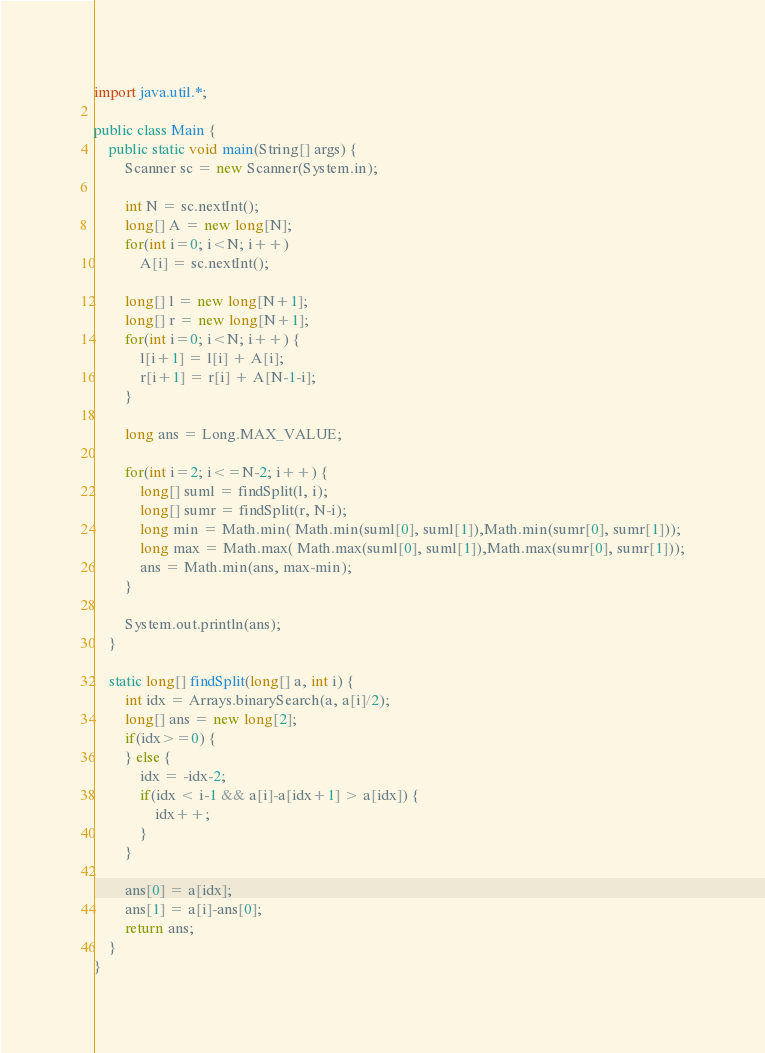<code> <loc_0><loc_0><loc_500><loc_500><_Java_>import java.util.*;

public class Main {
	public static void main(String[] args) {
		Scanner sc = new Scanner(System.in);
		
		int N = sc.nextInt();
		long[] A = new long[N];
		for(int i=0; i<N; i++)
			A[i] = sc.nextInt();
		
		long[] l = new long[N+1];
		long[] r = new long[N+1];
		for(int i=0; i<N; i++) {
			l[i+1] = l[i] + A[i];
			r[i+1] = r[i] + A[N-1-i];
		}
		
		long ans = Long.MAX_VALUE;
		
		for(int i=2; i<=N-2; i++) {
			long[] suml = findSplit(l, i);
			long[] sumr = findSplit(r, N-i);
			long min = Math.min( Math.min(suml[0], suml[1]),Math.min(sumr[0], sumr[1]));
			long max = Math.max( Math.max(suml[0], suml[1]),Math.max(sumr[0], sumr[1]));
			ans = Math.min(ans, max-min);
		}
		
		System.out.println(ans);
	}
	
	static long[] findSplit(long[] a, int i) {
		int idx = Arrays.binarySearch(a, a[i]/2);
		long[] ans = new long[2];
		if(idx>=0) {
		} else {
			idx = -idx-2;
			if(idx < i-1 && a[i]-a[idx+1] > a[idx]) {
				idx++;
			}
		}
		
		ans[0] = a[idx];
		ans[1] = a[i]-ans[0];
		return ans;
	}
}
</code> 